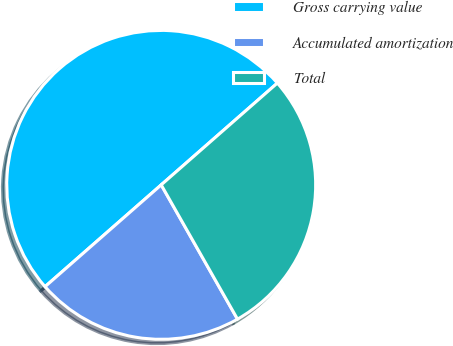Convert chart to OTSL. <chart><loc_0><loc_0><loc_500><loc_500><pie_chart><fcel>Gross carrying value<fcel>Accumulated amortization<fcel>Total<nl><fcel>50.0%<fcel>21.77%<fcel>28.23%<nl></chart> 